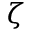<formula> <loc_0><loc_0><loc_500><loc_500>\zeta</formula> 